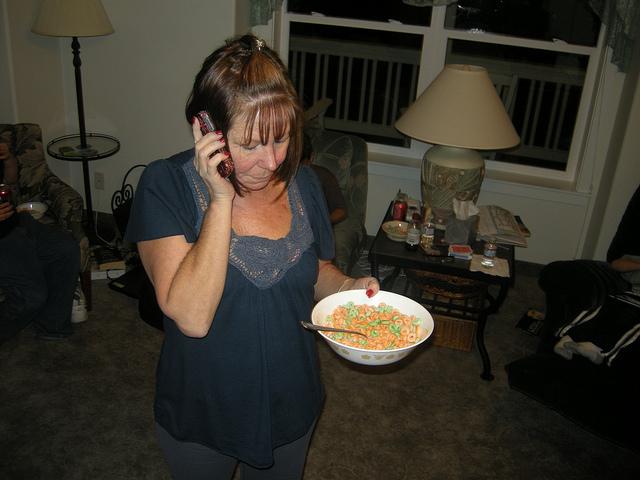What color nail does this woman have?
Write a very short answer. Red. What type of cereal is in the woman's bowl?
Concise answer only. Apple jacks. Is this woman sad?
Quick response, please. Yes. What is in the bowl?
Quick response, please. Cereal. What is the woman smelling?
Concise answer only. Cereal. What time of day is it?
Quick response, please. Night. Is the boy in the recliner wearing shoes?
Be succinct. No. What is on the woman's head?
Concise answer only. Hair clip. Is the woman wearing her hair down?
Answer briefly. No. What is in the woman's left hand?
Give a very brief answer. Cereal bowl. 